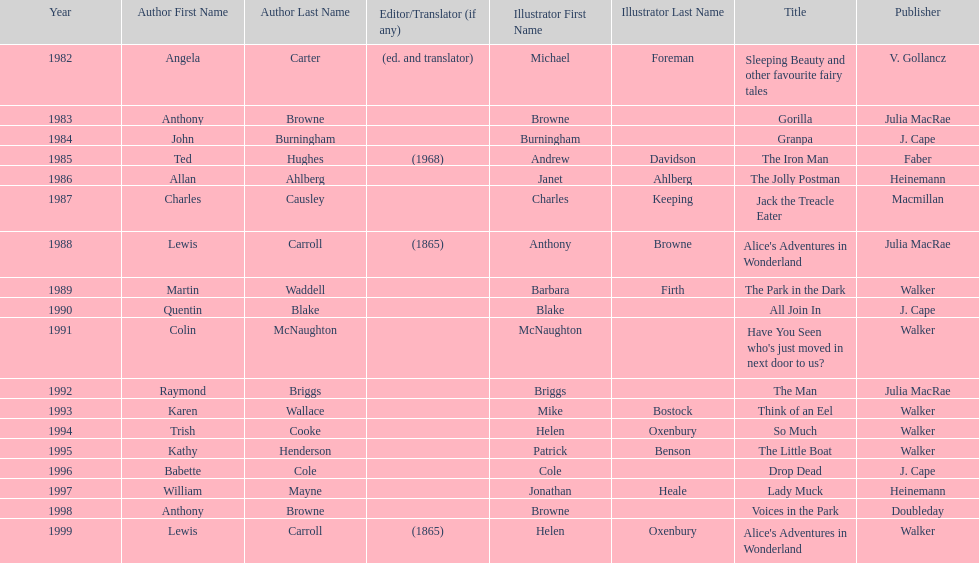How many titles had the same author listed as the illustrator? 7. 